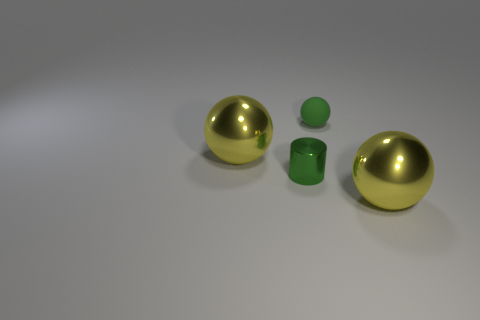Add 2 small green matte things. How many objects exist? 6 Subtract all cylinders. How many objects are left? 3 Subtract 0 blue spheres. How many objects are left? 4 Subtract all matte things. Subtract all large yellow shiny balls. How many objects are left? 1 Add 2 big balls. How many big balls are left? 4 Add 3 big red blocks. How many big red blocks exist? 3 